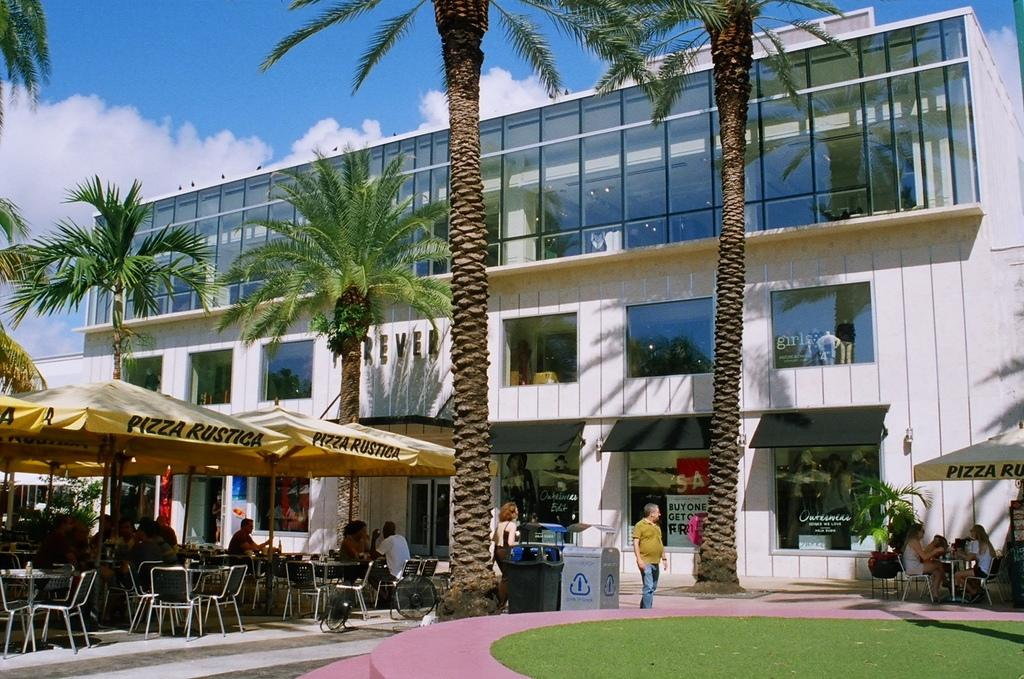What type of vegetation can be seen in the image? There is grass in the image. What type of structures are visible in the image? There are tents and buildings in the image. What feature do the buildings have? The buildings have windows. What other natural elements can be seen in the image? There are trees in the image. What part of the natural environment is visible in the image? The sky is visible in the image. What atmospheric conditions can be observed in the sky? There are clouds in the sky. What type of furniture is present in the image? There are chairs and tables in the image. Are there any people present in the image? Yes, there are people in the image. What object can be seen on the right side of the image? There is an umbrella on the right side of the image. What type of army is marching through the grass in the image? There is no army present in the image; it features grass, tents, buildings, trees, sky, clouds, chairs, tables, people, and an umbrella. What type of ray is swimming in the sky in the image? There is no ray present in the image; it features clouds in the sky. 